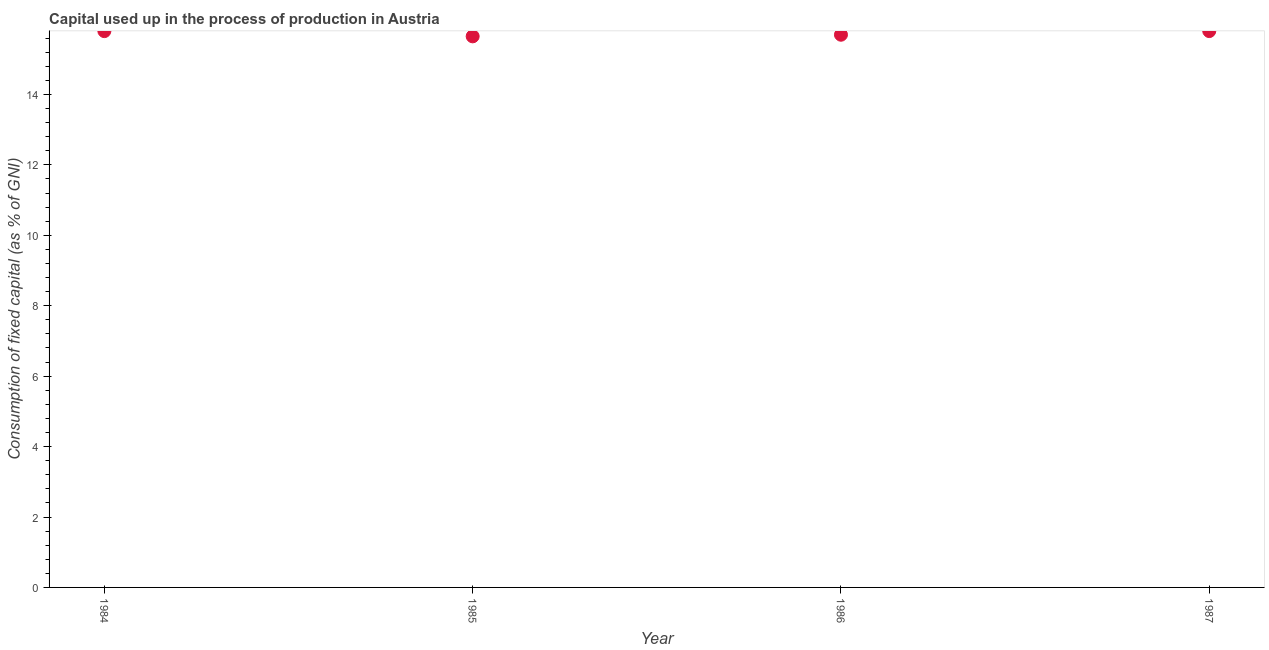What is the consumption of fixed capital in 1984?
Offer a terse response. 15.8. Across all years, what is the maximum consumption of fixed capital?
Provide a succinct answer. 15.8. Across all years, what is the minimum consumption of fixed capital?
Offer a very short reply. 15.65. What is the sum of the consumption of fixed capital?
Offer a very short reply. 62.95. What is the difference between the consumption of fixed capital in 1984 and 1985?
Make the answer very short. 0.15. What is the average consumption of fixed capital per year?
Offer a very short reply. 15.74. What is the median consumption of fixed capital?
Your answer should be compact. 15.75. In how many years, is the consumption of fixed capital greater than 0.8 %?
Offer a very short reply. 4. Do a majority of the years between 1986 and 1984 (inclusive) have consumption of fixed capital greater than 4 %?
Offer a very short reply. No. What is the ratio of the consumption of fixed capital in 1985 to that in 1986?
Your answer should be very brief. 1. Is the difference between the consumption of fixed capital in 1984 and 1987 greater than the difference between any two years?
Give a very brief answer. No. What is the difference between the highest and the second highest consumption of fixed capital?
Provide a succinct answer. 0. Is the sum of the consumption of fixed capital in 1984 and 1986 greater than the maximum consumption of fixed capital across all years?
Your answer should be very brief. Yes. What is the difference between the highest and the lowest consumption of fixed capital?
Your answer should be very brief. 0.15. In how many years, is the consumption of fixed capital greater than the average consumption of fixed capital taken over all years?
Ensure brevity in your answer.  2. Does the consumption of fixed capital monotonically increase over the years?
Your answer should be compact. No. How many years are there in the graph?
Ensure brevity in your answer.  4. What is the difference between two consecutive major ticks on the Y-axis?
Offer a terse response. 2. Are the values on the major ticks of Y-axis written in scientific E-notation?
Keep it short and to the point. No. Does the graph contain grids?
Make the answer very short. No. What is the title of the graph?
Offer a terse response. Capital used up in the process of production in Austria. What is the label or title of the Y-axis?
Keep it short and to the point. Consumption of fixed capital (as % of GNI). What is the Consumption of fixed capital (as % of GNI) in 1984?
Keep it short and to the point. 15.8. What is the Consumption of fixed capital (as % of GNI) in 1985?
Your answer should be compact. 15.65. What is the Consumption of fixed capital (as % of GNI) in 1986?
Provide a succinct answer. 15.7. What is the Consumption of fixed capital (as % of GNI) in 1987?
Provide a succinct answer. 15.8. What is the difference between the Consumption of fixed capital (as % of GNI) in 1984 and 1985?
Provide a short and direct response. 0.15. What is the difference between the Consumption of fixed capital (as % of GNI) in 1984 and 1986?
Your answer should be compact. 0.1. What is the difference between the Consumption of fixed capital (as % of GNI) in 1984 and 1987?
Ensure brevity in your answer.  -0. What is the difference between the Consumption of fixed capital (as % of GNI) in 1985 and 1986?
Provide a succinct answer. -0.05. What is the difference between the Consumption of fixed capital (as % of GNI) in 1985 and 1987?
Keep it short and to the point. -0.15. What is the difference between the Consumption of fixed capital (as % of GNI) in 1986 and 1987?
Ensure brevity in your answer.  -0.1. What is the ratio of the Consumption of fixed capital (as % of GNI) in 1984 to that in 1985?
Offer a terse response. 1.01. What is the ratio of the Consumption of fixed capital (as % of GNI) in 1984 to that in 1987?
Make the answer very short. 1. What is the ratio of the Consumption of fixed capital (as % of GNI) in 1986 to that in 1987?
Offer a very short reply. 0.99. 